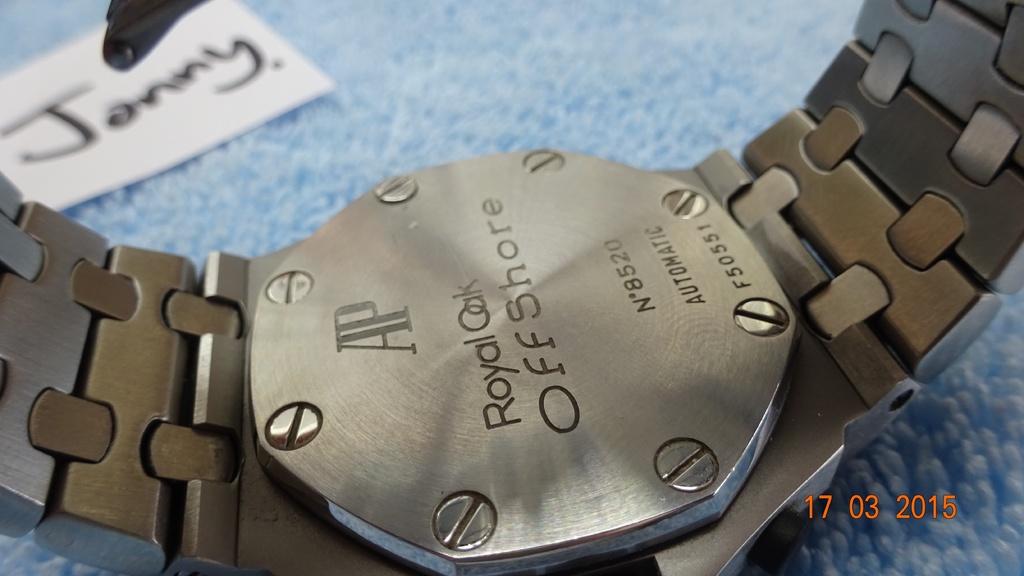What is the serial number of this watch?
Keep it short and to the point. F50551. What name is mentioned on the tag next to the watch?
Keep it short and to the point. Janny. 